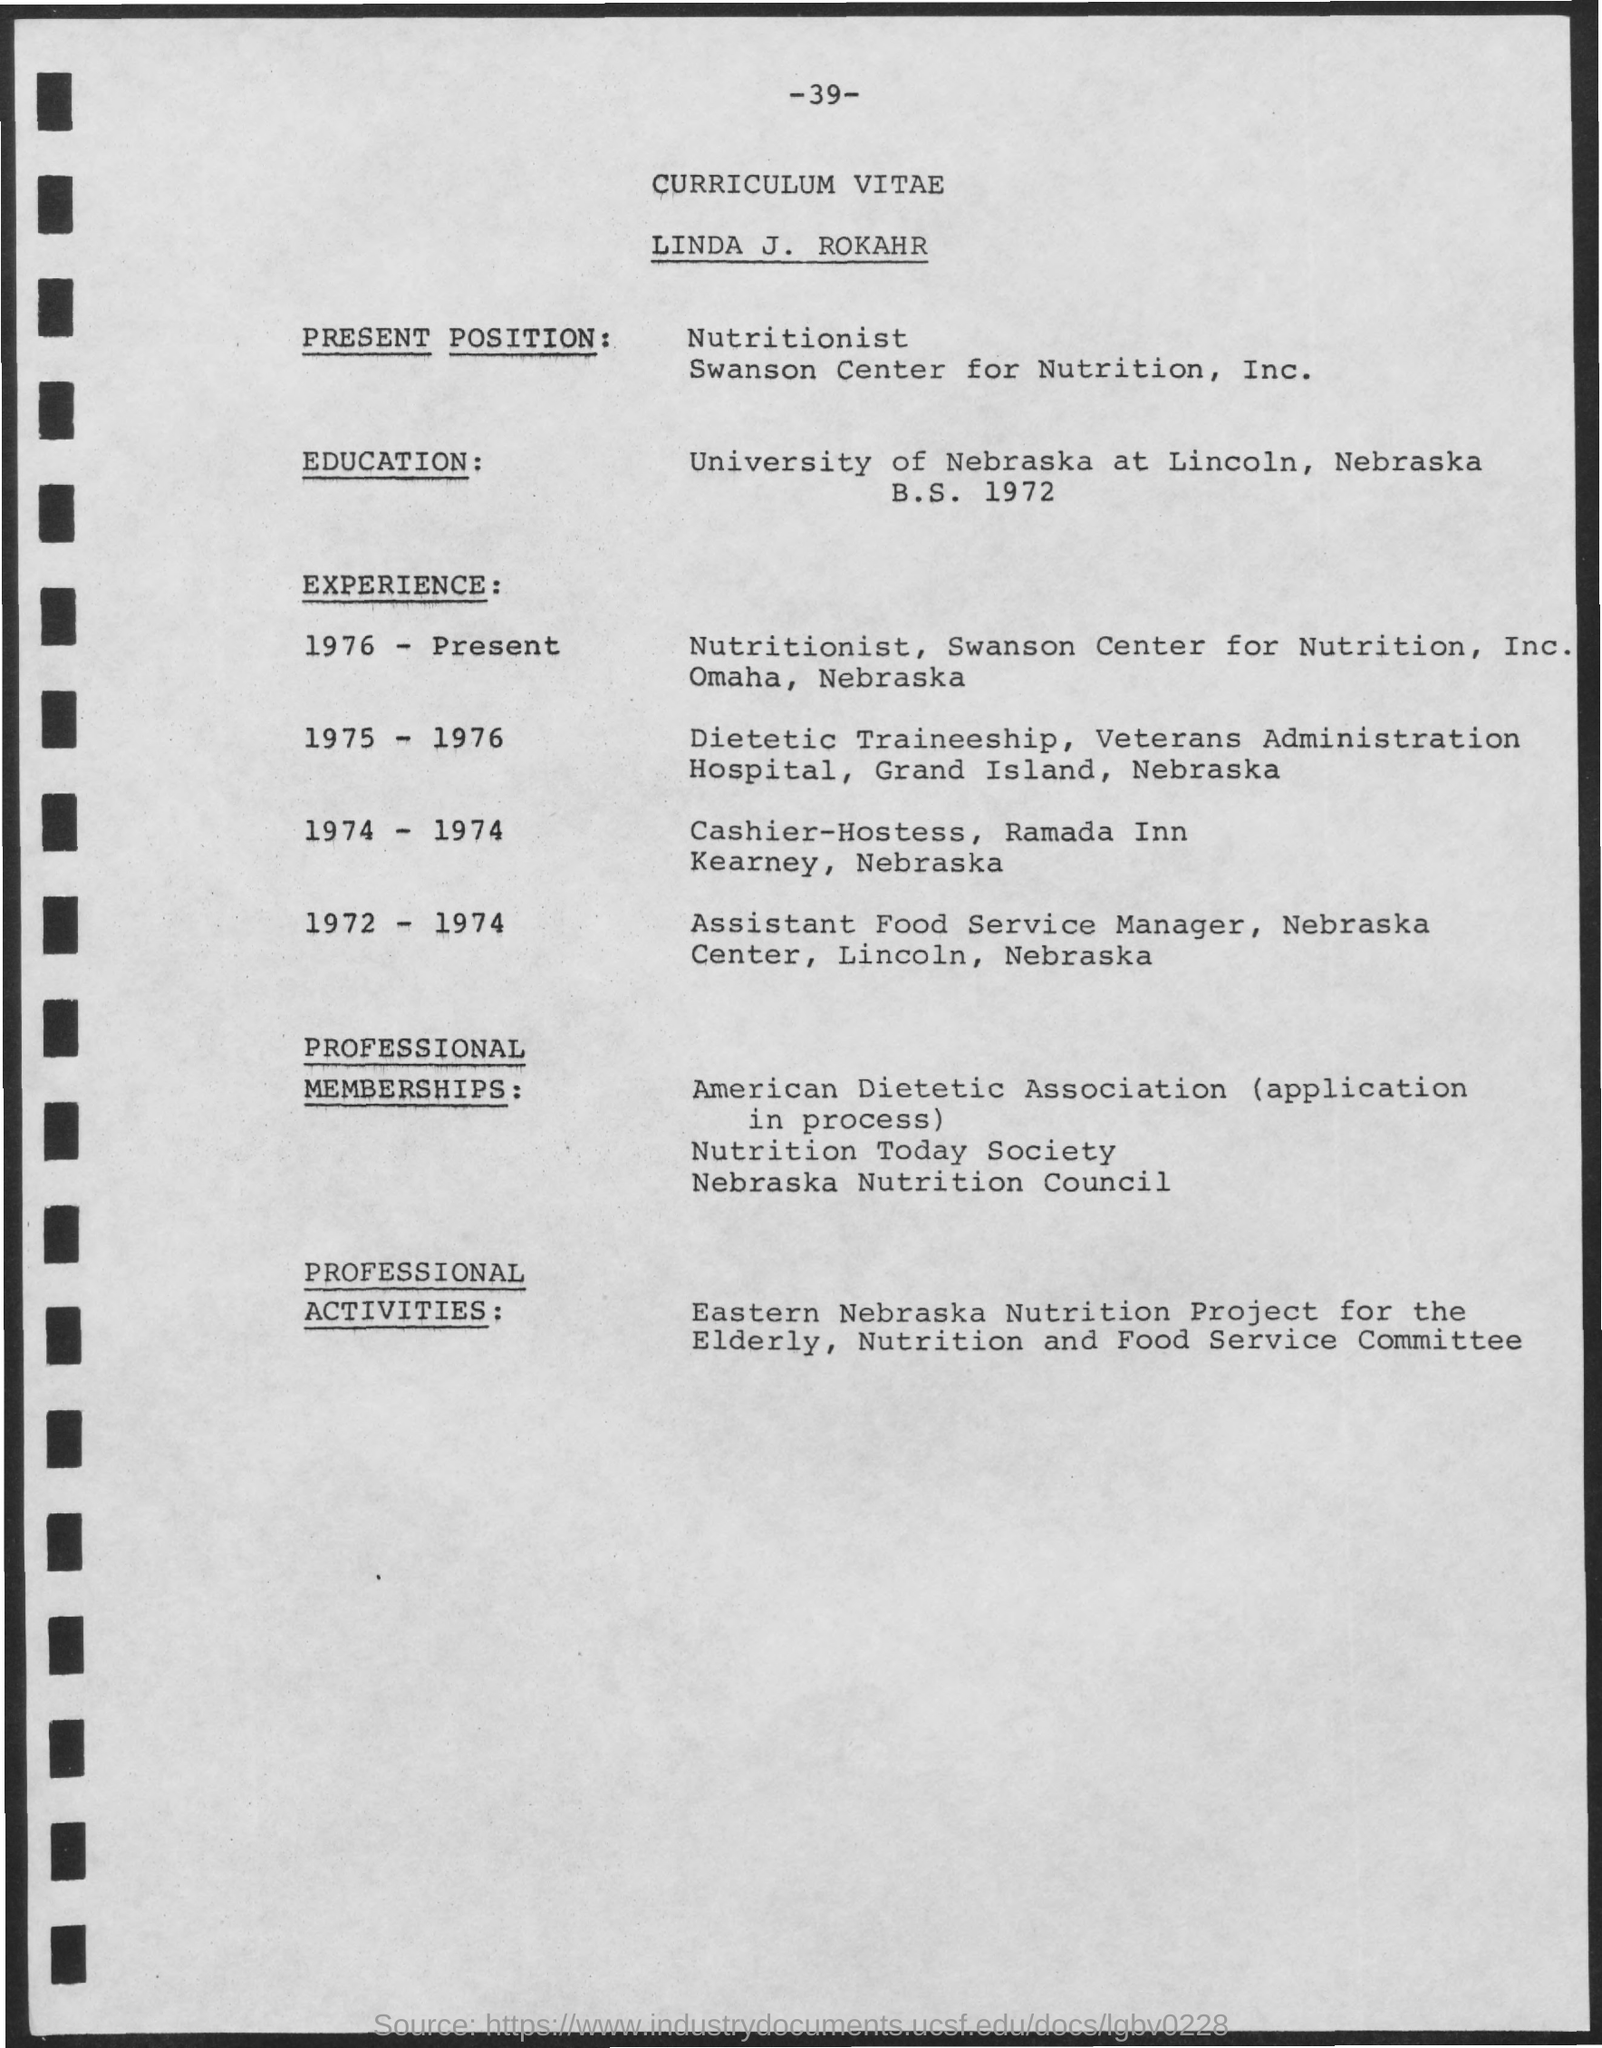What is the page number mentioned on the top
Your answer should be compact. -39-. What is title mentioned on the top of the page
Offer a very short reply. CURRICULUM VITAE. What is the current position of linda j. rokahr
Give a very brief answer. Nutritionist. In which university he did his education
Your answer should be compact. University of nebraska. 